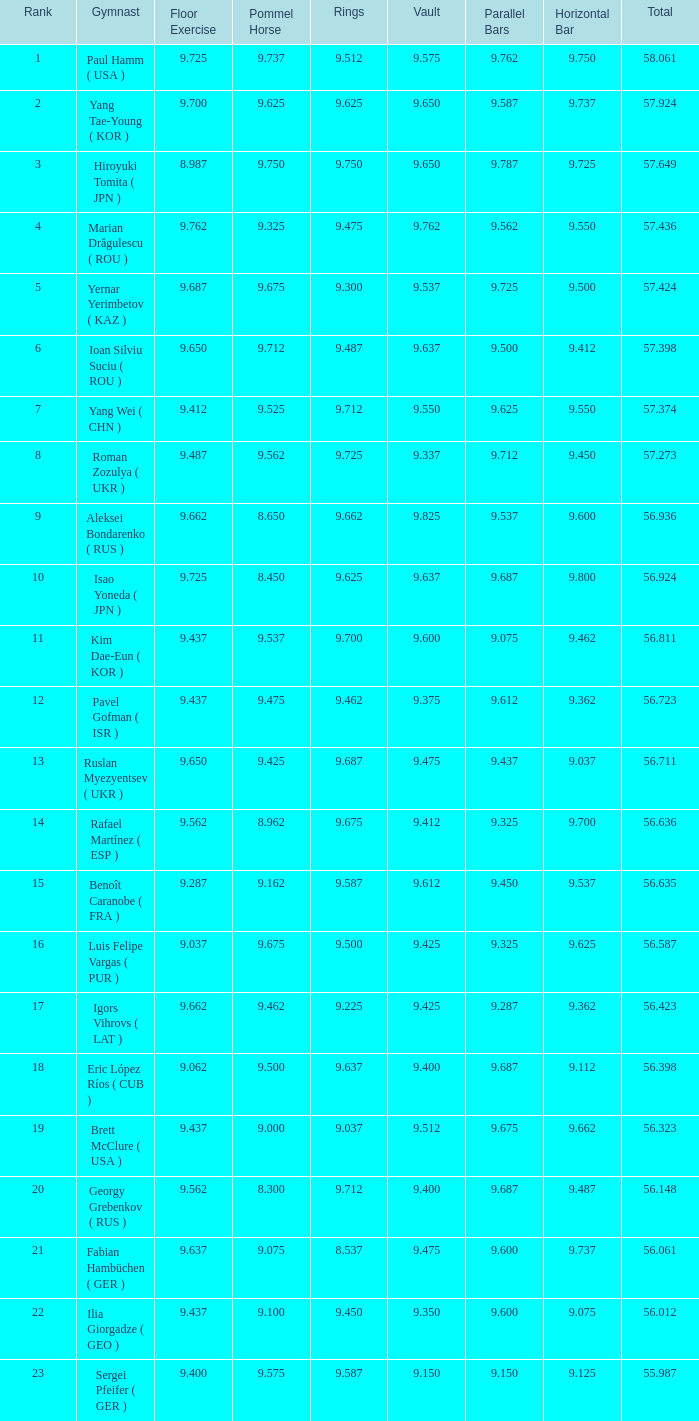287? 56.635. 